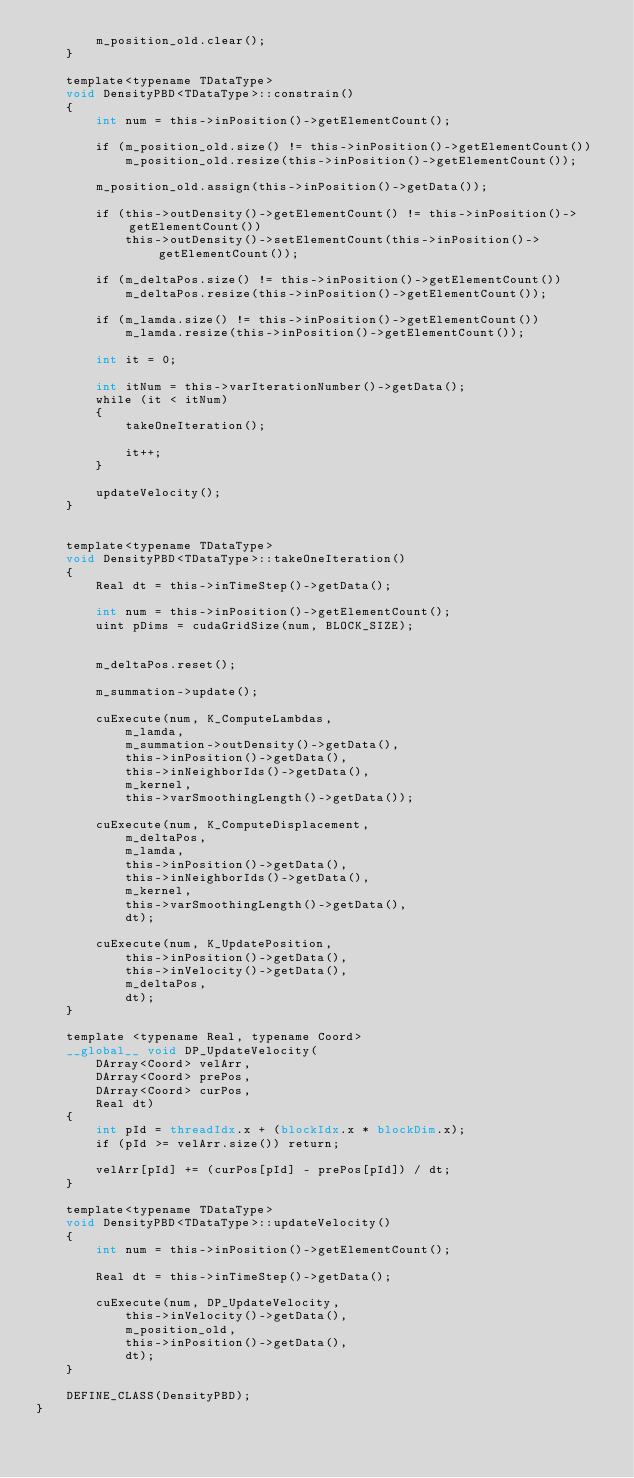<code> <loc_0><loc_0><loc_500><loc_500><_Cuda_>		m_position_old.clear();
	}

	template<typename TDataType>
	void DensityPBD<TDataType>::constrain()
	{
		int num = this->inPosition()->getElementCount();
		
		if (m_position_old.size() != this->inPosition()->getElementCount())
			m_position_old.resize(this->inPosition()->getElementCount());

		m_position_old.assign(this->inPosition()->getData());

		if (this->outDensity()->getElementCount() != this->inPosition()->getElementCount())
			this->outDensity()->setElementCount(this->inPosition()->getElementCount());

		if (m_deltaPos.size() != this->inPosition()->getElementCount())
			m_deltaPos.resize(this->inPosition()->getElementCount());

		if (m_lamda.size() != this->inPosition()->getElementCount())
			m_lamda.resize(this->inPosition()->getElementCount());

		int it = 0;

		int itNum = this->varIterationNumber()->getData();
		while (it < itNum)
		{
			takeOneIteration();

			it++;
		}

		updateVelocity();
	}


	template<typename TDataType>
	void DensityPBD<TDataType>::takeOneIteration()
	{
		Real dt = this->inTimeStep()->getData();

		int num = this->inPosition()->getElementCount();
		uint pDims = cudaGridSize(num, BLOCK_SIZE);

		
		m_deltaPos.reset();

		m_summation->update();

		cuExecute(num, K_ComputeLambdas,
			m_lamda,
			m_summation->outDensity()->getData(),
			this->inPosition()->getData(),
			this->inNeighborIds()->getData(),
			m_kernel,
			this->varSmoothingLength()->getData());

		cuExecute(num, K_ComputeDisplacement,
			m_deltaPos,
			m_lamda,
			this->inPosition()->getData(),
			this->inNeighborIds()->getData(),
			m_kernel,
			this->varSmoothingLength()->getData(),
			dt);

		cuExecute(num, K_UpdatePosition,
			this->inPosition()->getData(),
			this->inVelocity()->getData(),
			m_deltaPos,
			dt);
	}

	template <typename Real, typename Coord>
	__global__ void DP_UpdateVelocity(
		DArray<Coord> velArr,
		DArray<Coord> prePos,
		DArray<Coord> curPos,
		Real dt)
	{
		int pId = threadIdx.x + (blockIdx.x * blockDim.x);
		if (pId >= velArr.size()) return;

		velArr[pId] += (curPos[pId] - prePos[pId]) / dt;
	}

	template<typename TDataType>
	void DensityPBD<TDataType>::updateVelocity()
	{
		int num = this->inPosition()->getElementCount();

		Real dt = this->inTimeStep()->getData();

		cuExecute(num, DP_UpdateVelocity,
			this->inVelocity()->getData(),
			m_position_old,
			this->inPosition()->getData(),
			dt);
	}

	DEFINE_CLASS(DensityPBD);
}</code> 